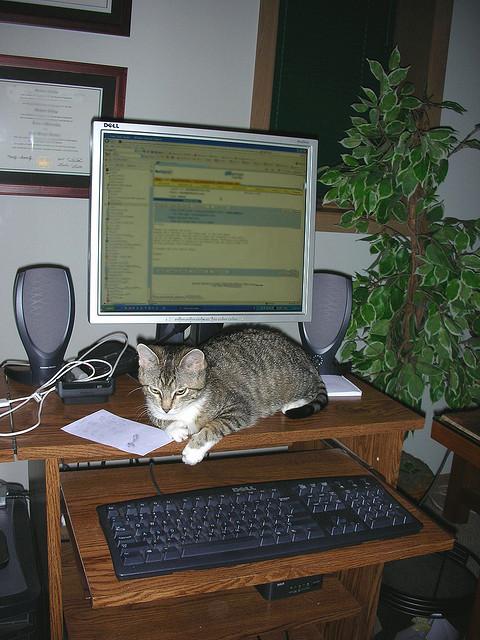Is the monitor on?
Give a very brief answer. Yes. Where is the cat laying?
Quick response, please. Desk. How many speakers are there?
Give a very brief answer. 2. Is the cat laying between two computers?
Write a very short answer. No. 